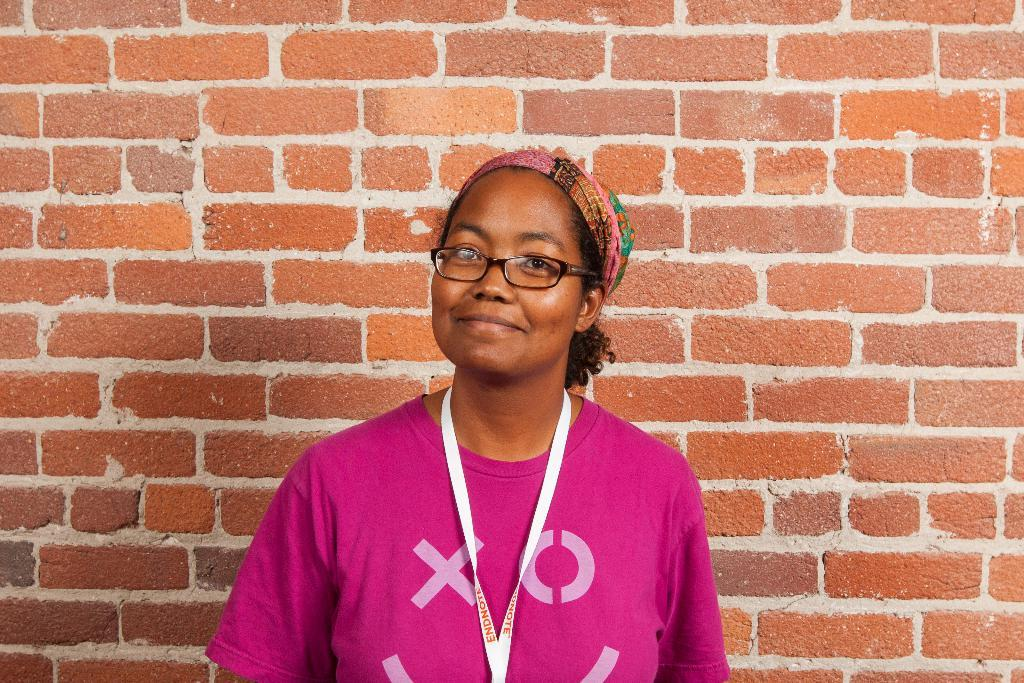Who or what is present in the image? There is a person in the image. What is the facial expression of the person? The person has a smile on her face. What can be seen in the background of the image? There is a brick wall in the background of the image. What type of beef can be seen hanging from the window in the image? There is no window or beef present in the image. 